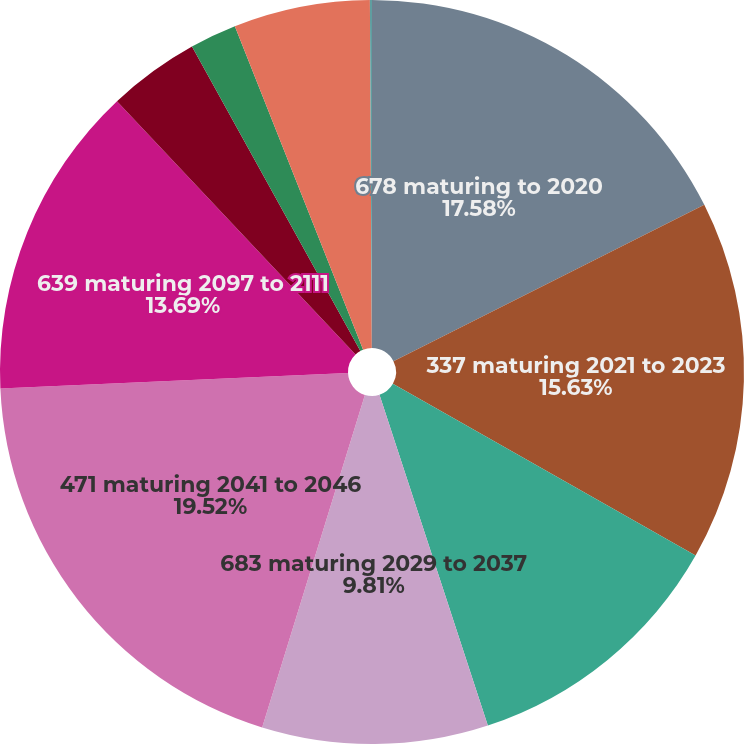<chart> <loc_0><loc_0><loc_500><loc_500><pie_chart><fcel>678 maturing to 2020<fcel>337 maturing 2021 to 2023<fcel>571 maturing 2024 to 2027<fcel>683 maturing 2029 to 2037<fcel>471 maturing 2041 to 2046<fcel>639 maturing 2097 to 2111<fcel>Securitization borrowings 148<fcel>Other debt 821 maturing to<fcel>Discounts and premiums net<fcel>Debt issuance costs<nl><fcel>17.58%<fcel>15.63%<fcel>11.75%<fcel>9.81%<fcel>19.52%<fcel>13.69%<fcel>3.98%<fcel>2.03%<fcel>5.92%<fcel>0.09%<nl></chart> 